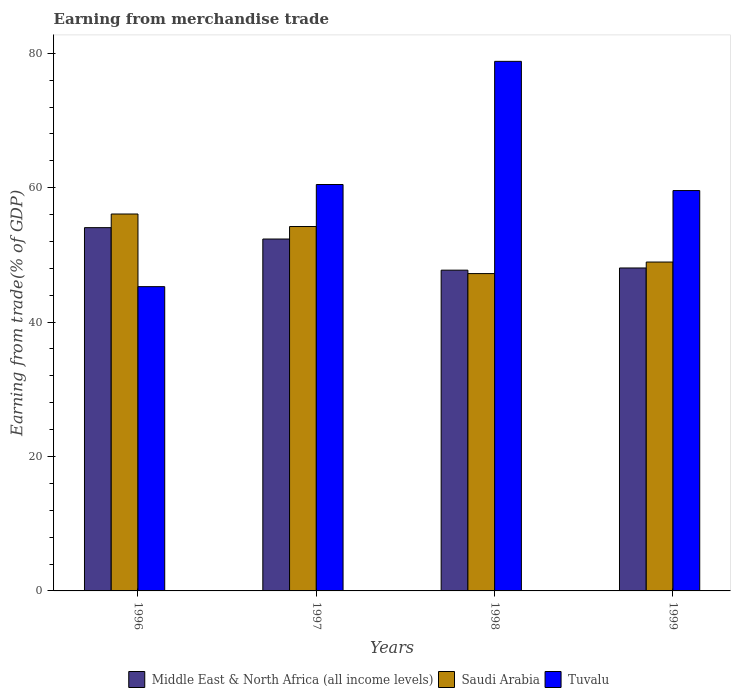How many groups of bars are there?
Offer a terse response. 4. Are the number of bars per tick equal to the number of legend labels?
Your answer should be very brief. Yes. Are the number of bars on each tick of the X-axis equal?
Keep it short and to the point. Yes. What is the earnings from trade in Saudi Arabia in 1996?
Your response must be concise. 56.09. Across all years, what is the maximum earnings from trade in Saudi Arabia?
Offer a very short reply. 56.09. Across all years, what is the minimum earnings from trade in Tuvalu?
Make the answer very short. 45.28. In which year was the earnings from trade in Saudi Arabia maximum?
Offer a terse response. 1996. What is the total earnings from trade in Middle East & North Africa (all income levels) in the graph?
Ensure brevity in your answer.  202.2. What is the difference between the earnings from trade in Middle East & North Africa (all income levels) in 1997 and that in 1999?
Keep it short and to the point. 4.31. What is the difference between the earnings from trade in Saudi Arabia in 1998 and the earnings from trade in Tuvalu in 1999?
Offer a terse response. -12.36. What is the average earnings from trade in Saudi Arabia per year?
Make the answer very short. 51.62. In the year 1997, what is the difference between the earnings from trade in Tuvalu and earnings from trade in Saudi Arabia?
Ensure brevity in your answer.  6.25. In how many years, is the earnings from trade in Saudi Arabia greater than 40 %?
Your answer should be compact. 4. What is the ratio of the earnings from trade in Saudi Arabia in 1997 to that in 1998?
Provide a short and direct response. 1.15. Is the difference between the earnings from trade in Tuvalu in 1996 and 1998 greater than the difference between the earnings from trade in Saudi Arabia in 1996 and 1998?
Keep it short and to the point. No. What is the difference between the highest and the second highest earnings from trade in Tuvalu?
Offer a terse response. 18.33. What is the difference between the highest and the lowest earnings from trade in Saudi Arabia?
Give a very brief answer. 8.87. In how many years, is the earnings from trade in Saudi Arabia greater than the average earnings from trade in Saudi Arabia taken over all years?
Your response must be concise. 2. Is the sum of the earnings from trade in Tuvalu in 1996 and 1999 greater than the maximum earnings from trade in Saudi Arabia across all years?
Provide a succinct answer. Yes. What does the 1st bar from the left in 1998 represents?
Offer a very short reply. Middle East & North Africa (all income levels). What does the 3rd bar from the right in 1996 represents?
Your answer should be compact. Middle East & North Africa (all income levels). Is it the case that in every year, the sum of the earnings from trade in Middle East & North Africa (all income levels) and earnings from trade in Tuvalu is greater than the earnings from trade in Saudi Arabia?
Offer a terse response. Yes. How many bars are there?
Your response must be concise. 12. Are all the bars in the graph horizontal?
Give a very brief answer. No. Are the values on the major ticks of Y-axis written in scientific E-notation?
Make the answer very short. No. Does the graph contain grids?
Your answer should be very brief. No. How are the legend labels stacked?
Offer a very short reply. Horizontal. What is the title of the graph?
Keep it short and to the point. Earning from merchandise trade. Does "St. Vincent and the Grenadines" appear as one of the legend labels in the graph?
Your answer should be compact. No. What is the label or title of the X-axis?
Offer a terse response. Years. What is the label or title of the Y-axis?
Offer a terse response. Earning from trade(% of GDP). What is the Earning from trade(% of GDP) of Middle East & North Africa (all income levels) in 1996?
Give a very brief answer. 54.06. What is the Earning from trade(% of GDP) of Saudi Arabia in 1996?
Your answer should be very brief. 56.09. What is the Earning from trade(% of GDP) in Tuvalu in 1996?
Your response must be concise. 45.28. What is the Earning from trade(% of GDP) in Middle East & North Africa (all income levels) in 1997?
Provide a short and direct response. 52.36. What is the Earning from trade(% of GDP) of Saudi Arabia in 1997?
Provide a short and direct response. 54.22. What is the Earning from trade(% of GDP) in Tuvalu in 1997?
Your answer should be very brief. 60.48. What is the Earning from trade(% of GDP) of Middle East & North Africa (all income levels) in 1998?
Provide a short and direct response. 47.73. What is the Earning from trade(% of GDP) in Saudi Arabia in 1998?
Give a very brief answer. 47.22. What is the Earning from trade(% of GDP) of Tuvalu in 1998?
Offer a very short reply. 78.8. What is the Earning from trade(% of GDP) of Middle East & North Africa (all income levels) in 1999?
Offer a very short reply. 48.05. What is the Earning from trade(% of GDP) of Saudi Arabia in 1999?
Provide a succinct answer. 48.94. What is the Earning from trade(% of GDP) in Tuvalu in 1999?
Your response must be concise. 59.58. Across all years, what is the maximum Earning from trade(% of GDP) of Middle East & North Africa (all income levels)?
Provide a short and direct response. 54.06. Across all years, what is the maximum Earning from trade(% of GDP) of Saudi Arabia?
Keep it short and to the point. 56.09. Across all years, what is the maximum Earning from trade(% of GDP) in Tuvalu?
Give a very brief answer. 78.8. Across all years, what is the minimum Earning from trade(% of GDP) of Middle East & North Africa (all income levels)?
Provide a short and direct response. 47.73. Across all years, what is the minimum Earning from trade(% of GDP) in Saudi Arabia?
Provide a succinct answer. 47.22. Across all years, what is the minimum Earning from trade(% of GDP) in Tuvalu?
Keep it short and to the point. 45.28. What is the total Earning from trade(% of GDP) in Middle East & North Africa (all income levels) in the graph?
Your answer should be very brief. 202.2. What is the total Earning from trade(% of GDP) in Saudi Arabia in the graph?
Offer a very short reply. 206.47. What is the total Earning from trade(% of GDP) in Tuvalu in the graph?
Ensure brevity in your answer.  244.13. What is the difference between the Earning from trade(% of GDP) in Middle East & North Africa (all income levels) in 1996 and that in 1997?
Your answer should be compact. 1.69. What is the difference between the Earning from trade(% of GDP) in Saudi Arabia in 1996 and that in 1997?
Give a very brief answer. 1.86. What is the difference between the Earning from trade(% of GDP) of Tuvalu in 1996 and that in 1997?
Your answer should be compact. -15.2. What is the difference between the Earning from trade(% of GDP) in Middle East & North Africa (all income levels) in 1996 and that in 1998?
Make the answer very short. 6.33. What is the difference between the Earning from trade(% of GDP) of Saudi Arabia in 1996 and that in 1998?
Provide a succinct answer. 8.87. What is the difference between the Earning from trade(% of GDP) in Tuvalu in 1996 and that in 1998?
Give a very brief answer. -33.52. What is the difference between the Earning from trade(% of GDP) in Middle East & North Africa (all income levels) in 1996 and that in 1999?
Offer a very short reply. 6. What is the difference between the Earning from trade(% of GDP) of Saudi Arabia in 1996 and that in 1999?
Offer a very short reply. 7.15. What is the difference between the Earning from trade(% of GDP) of Tuvalu in 1996 and that in 1999?
Your response must be concise. -14.3. What is the difference between the Earning from trade(% of GDP) in Middle East & North Africa (all income levels) in 1997 and that in 1998?
Ensure brevity in your answer.  4.63. What is the difference between the Earning from trade(% of GDP) of Saudi Arabia in 1997 and that in 1998?
Your response must be concise. 7. What is the difference between the Earning from trade(% of GDP) in Tuvalu in 1997 and that in 1998?
Your answer should be compact. -18.33. What is the difference between the Earning from trade(% of GDP) of Middle East & North Africa (all income levels) in 1997 and that in 1999?
Offer a terse response. 4.31. What is the difference between the Earning from trade(% of GDP) in Saudi Arabia in 1997 and that in 1999?
Provide a succinct answer. 5.28. What is the difference between the Earning from trade(% of GDP) of Tuvalu in 1997 and that in 1999?
Your answer should be compact. 0.9. What is the difference between the Earning from trade(% of GDP) in Middle East & North Africa (all income levels) in 1998 and that in 1999?
Provide a short and direct response. -0.33. What is the difference between the Earning from trade(% of GDP) in Saudi Arabia in 1998 and that in 1999?
Offer a terse response. -1.72. What is the difference between the Earning from trade(% of GDP) in Tuvalu in 1998 and that in 1999?
Your response must be concise. 19.23. What is the difference between the Earning from trade(% of GDP) in Middle East & North Africa (all income levels) in 1996 and the Earning from trade(% of GDP) in Saudi Arabia in 1997?
Offer a terse response. -0.17. What is the difference between the Earning from trade(% of GDP) in Middle East & North Africa (all income levels) in 1996 and the Earning from trade(% of GDP) in Tuvalu in 1997?
Make the answer very short. -6.42. What is the difference between the Earning from trade(% of GDP) of Saudi Arabia in 1996 and the Earning from trade(% of GDP) of Tuvalu in 1997?
Ensure brevity in your answer.  -4.39. What is the difference between the Earning from trade(% of GDP) in Middle East & North Africa (all income levels) in 1996 and the Earning from trade(% of GDP) in Saudi Arabia in 1998?
Your response must be concise. 6.83. What is the difference between the Earning from trade(% of GDP) of Middle East & North Africa (all income levels) in 1996 and the Earning from trade(% of GDP) of Tuvalu in 1998?
Offer a very short reply. -24.75. What is the difference between the Earning from trade(% of GDP) of Saudi Arabia in 1996 and the Earning from trade(% of GDP) of Tuvalu in 1998?
Offer a terse response. -22.71. What is the difference between the Earning from trade(% of GDP) of Middle East & North Africa (all income levels) in 1996 and the Earning from trade(% of GDP) of Saudi Arabia in 1999?
Your answer should be very brief. 5.12. What is the difference between the Earning from trade(% of GDP) in Middle East & North Africa (all income levels) in 1996 and the Earning from trade(% of GDP) in Tuvalu in 1999?
Offer a terse response. -5.52. What is the difference between the Earning from trade(% of GDP) of Saudi Arabia in 1996 and the Earning from trade(% of GDP) of Tuvalu in 1999?
Keep it short and to the point. -3.49. What is the difference between the Earning from trade(% of GDP) of Middle East & North Africa (all income levels) in 1997 and the Earning from trade(% of GDP) of Saudi Arabia in 1998?
Offer a very short reply. 5.14. What is the difference between the Earning from trade(% of GDP) in Middle East & North Africa (all income levels) in 1997 and the Earning from trade(% of GDP) in Tuvalu in 1998?
Your answer should be compact. -26.44. What is the difference between the Earning from trade(% of GDP) of Saudi Arabia in 1997 and the Earning from trade(% of GDP) of Tuvalu in 1998?
Ensure brevity in your answer.  -24.58. What is the difference between the Earning from trade(% of GDP) in Middle East & North Africa (all income levels) in 1997 and the Earning from trade(% of GDP) in Saudi Arabia in 1999?
Your answer should be very brief. 3.42. What is the difference between the Earning from trade(% of GDP) of Middle East & North Africa (all income levels) in 1997 and the Earning from trade(% of GDP) of Tuvalu in 1999?
Your answer should be very brief. -7.21. What is the difference between the Earning from trade(% of GDP) in Saudi Arabia in 1997 and the Earning from trade(% of GDP) in Tuvalu in 1999?
Your answer should be very brief. -5.35. What is the difference between the Earning from trade(% of GDP) of Middle East & North Africa (all income levels) in 1998 and the Earning from trade(% of GDP) of Saudi Arabia in 1999?
Offer a very short reply. -1.21. What is the difference between the Earning from trade(% of GDP) of Middle East & North Africa (all income levels) in 1998 and the Earning from trade(% of GDP) of Tuvalu in 1999?
Keep it short and to the point. -11.85. What is the difference between the Earning from trade(% of GDP) of Saudi Arabia in 1998 and the Earning from trade(% of GDP) of Tuvalu in 1999?
Keep it short and to the point. -12.36. What is the average Earning from trade(% of GDP) in Middle East & North Africa (all income levels) per year?
Provide a short and direct response. 50.55. What is the average Earning from trade(% of GDP) of Saudi Arabia per year?
Keep it short and to the point. 51.62. What is the average Earning from trade(% of GDP) of Tuvalu per year?
Provide a short and direct response. 61.03. In the year 1996, what is the difference between the Earning from trade(% of GDP) of Middle East & North Africa (all income levels) and Earning from trade(% of GDP) of Saudi Arabia?
Your answer should be compact. -2.03. In the year 1996, what is the difference between the Earning from trade(% of GDP) in Middle East & North Africa (all income levels) and Earning from trade(% of GDP) in Tuvalu?
Give a very brief answer. 8.78. In the year 1996, what is the difference between the Earning from trade(% of GDP) of Saudi Arabia and Earning from trade(% of GDP) of Tuvalu?
Provide a succinct answer. 10.81. In the year 1997, what is the difference between the Earning from trade(% of GDP) of Middle East & North Africa (all income levels) and Earning from trade(% of GDP) of Saudi Arabia?
Provide a short and direct response. -1.86. In the year 1997, what is the difference between the Earning from trade(% of GDP) in Middle East & North Africa (all income levels) and Earning from trade(% of GDP) in Tuvalu?
Give a very brief answer. -8.11. In the year 1997, what is the difference between the Earning from trade(% of GDP) of Saudi Arabia and Earning from trade(% of GDP) of Tuvalu?
Offer a very short reply. -6.25. In the year 1998, what is the difference between the Earning from trade(% of GDP) of Middle East & North Africa (all income levels) and Earning from trade(% of GDP) of Saudi Arabia?
Ensure brevity in your answer.  0.51. In the year 1998, what is the difference between the Earning from trade(% of GDP) of Middle East & North Africa (all income levels) and Earning from trade(% of GDP) of Tuvalu?
Offer a very short reply. -31.07. In the year 1998, what is the difference between the Earning from trade(% of GDP) in Saudi Arabia and Earning from trade(% of GDP) in Tuvalu?
Ensure brevity in your answer.  -31.58. In the year 1999, what is the difference between the Earning from trade(% of GDP) in Middle East & North Africa (all income levels) and Earning from trade(% of GDP) in Saudi Arabia?
Provide a succinct answer. -0.89. In the year 1999, what is the difference between the Earning from trade(% of GDP) in Middle East & North Africa (all income levels) and Earning from trade(% of GDP) in Tuvalu?
Offer a very short reply. -11.52. In the year 1999, what is the difference between the Earning from trade(% of GDP) of Saudi Arabia and Earning from trade(% of GDP) of Tuvalu?
Provide a short and direct response. -10.64. What is the ratio of the Earning from trade(% of GDP) of Middle East & North Africa (all income levels) in 1996 to that in 1997?
Ensure brevity in your answer.  1.03. What is the ratio of the Earning from trade(% of GDP) in Saudi Arabia in 1996 to that in 1997?
Give a very brief answer. 1.03. What is the ratio of the Earning from trade(% of GDP) of Tuvalu in 1996 to that in 1997?
Offer a very short reply. 0.75. What is the ratio of the Earning from trade(% of GDP) in Middle East & North Africa (all income levels) in 1996 to that in 1998?
Give a very brief answer. 1.13. What is the ratio of the Earning from trade(% of GDP) in Saudi Arabia in 1996 to that in 1998?
Offer a terse response. 1.19. What is the ratio of the Earning from trade(% of GDP) of Tuvalu in 1996 to that in 1998?
Your response must be concise. 0.57. What is the ratio of the Earning from trade(% of GDP) of Middle East & North Africa (all income levels) in 1996 to that in 1999?
Provide a short and direct response. 1.12. What is the ratio of the Earning from trade(% of GDP) in Saudi Arabia in 1996 to that in 1999?
Offer a very short reply. 1.15. What is the ratio of the Earning from trade(% of GDP) in Tuvalu in 1996 to that in 1999?
Make the answer very short. 0.76. What is the ratio of the Earning from trade(% of GDP) in Middle East & North Africa (all income levels) in 1997 to that in 1998?
Your response must be concise. 1.1. What is the ratio of the Earning from trade(% of GDP) of Saudi Arabia in 1997 to that in 1998?
Give a very brief answer. 1.15. What is the ratio of the Earning from trade(% of GDP) of Tuvalu in 1997 to that in 1998?
Offer a terse response. 0.77. What is the ratio of the Earning from trade(% of GDP) of Middle East & North Africa (all income levels) in 1997 to that in 1999?
Offer a terse response. 1.09. What is the ratio of the Earning from trade(% of GDP) in Saudi Arabia in 1997 to that in 1999?
Offer a terse response. 1.11. What is the ratio of the Earning from trade(% of GDP) of Tuvalu in 1997 to that in 1999?
Offer a very short reply. 1.02. What is the ratio of the Earning from trade(% of GDP) of Middle East & North Africa (all income levels) in 1998 to that in 1999?
Your answer should be very brief. 0.99. What is the ratio of the Earning from trade(% of GDP) in Saudi Arabia in 1998 to that in 1999?
Give a very brief answer. 0.96. What is the ratio of the Earning from trade(% of GDP) in Tuvalu in 1998 to that in 1999?
Your answer should be compact. 1.32. What is the difference between the highest and the second highest Earning from trade(% of GDP) of Middle East & North Africa (all income levels)?
Offer a terse response. 1.69. What is the difference between the highest and the second highest Earning from trade(% of GDP) in Saudi Arabia?
Offer a very short reply. 1.86. What is the difference between the highest and the second highest Earning from trade(% of GDP) in Tuvalu?
Ensure brevity in your answer.  18.33. What is the difference between the highest and the lowest Earning from trade(% of GDP) of Middle East & North Africa (all income levels)?
Your answer should be compact. 6.33. What is the difference between the highest and the lowest Earning from trade(% of GDP) of Saudi Arabia?
Give a very brief answer. 8.87. What is the difference between the highest and the lowest Earning from trade(% of GDP) in Tuvalu?
Offer a terse response. 33.52. 